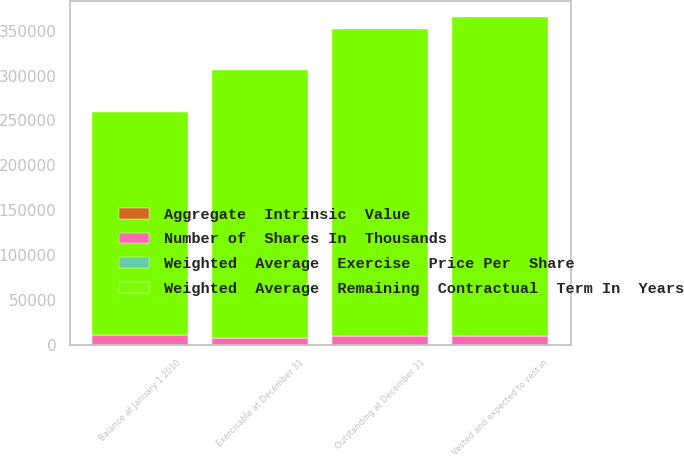Convert chart. <chart><loc_0><loc_0><loc_500><loc_500><stacked_bar_chart><ecel><fcel>Balance at January 1 2010<fcel>Outstanding at December 31<fcel>Vested and expected to vest in<fcel>Exercisable at December 31<nl><fcel>Number of  Shares In  Thousands<fcel>10705<fcel>9749<fcel>9326<fcel>6988<nl><fcel>Aggregate  Intrinsic  Value<fcel>15.37<fcel>17.18<fcel>16.25<fcel>9.5<nl><fcel>Weighted  Average  Exercise  Price Per  Share<fcel>5.9<fcel>5.2<fcel>5<fcel>3.9<nl><fcel>Weighted  Average  Remaining  Contractual  Term In  Years<fcel>248288<fcel>342241<fcel>355995<fcel>298937<nl></chart> 